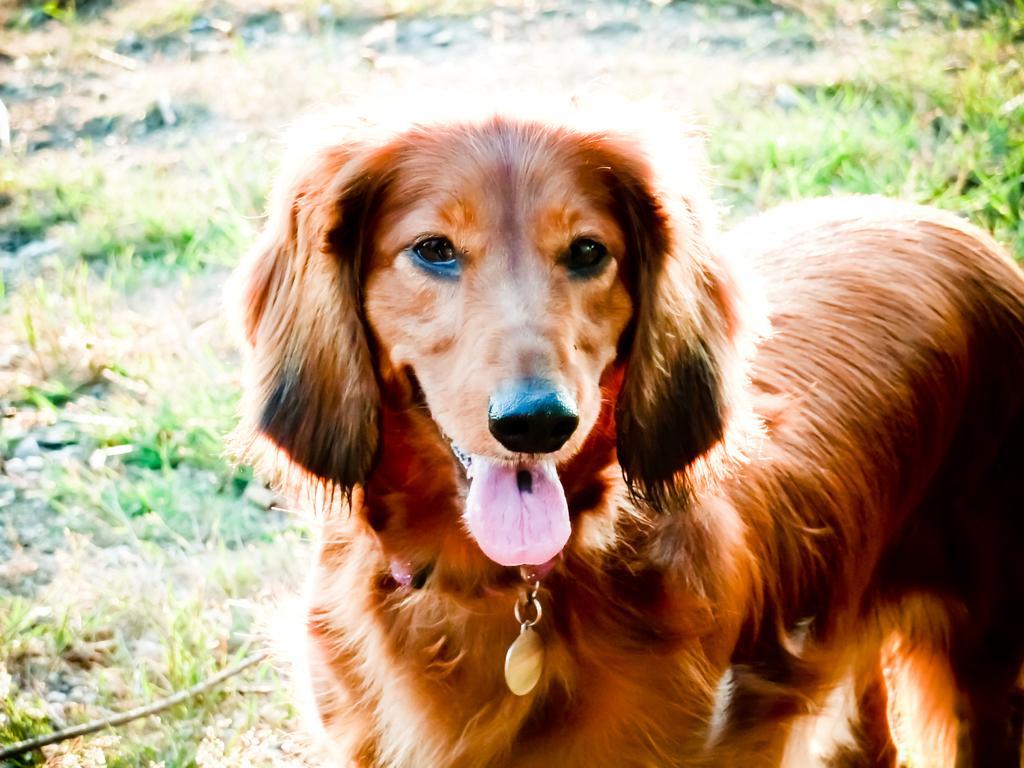Could you give a brief overview of what you see in this image? In this image in the foreground there is one dog, and in the background there is some grass. 